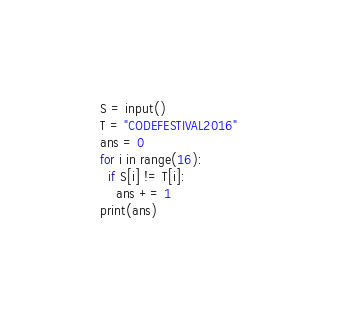<code> <loc_0><loc_0><loc_500><loc_500><_Python_>S = input()
T = "CODEFESTIVAL2016"
ans = 0
for i in range(16):
  if S[i] != T[i]:
    ans += 1
print(ans)</code> 